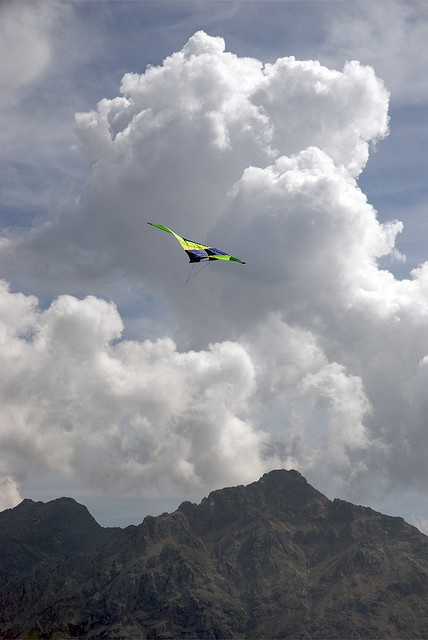Describe the objects in this image and their specific colors. I can see a kite in gray, black, and khaki tones in this image. 